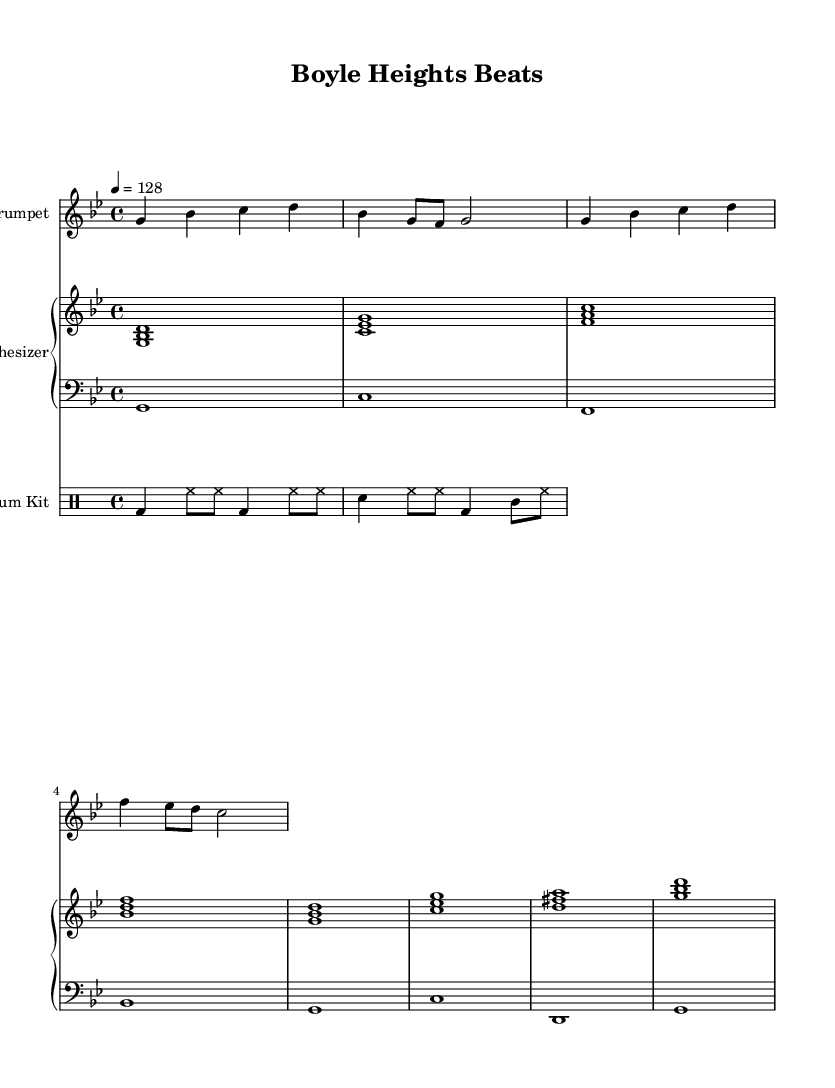What is the key signature of this music? The key signature indicates that the piece is in G minor, which typically has two flats (B flat and E flat). This can be inferred from the key signature symbol located at the beginning of the staff.
Answer: G minor What is the time signature of this piece? The time signature is shown as 4/4 at the beginning of the score, which means there are four beats in each measure and a quarter note gets one beat.
Answer: 4/4 What is the tempo of this composition? The tempo marking indicates that the piece is to be played at 128 beats per minute, which is noted in the tempo indication (4 = 128) at the top of the score.
Answer: 128 How many measures are in the mariachi trumpet part? By counting the measures in the mariachi trumpet staff, there are a total of 4 measures presented in the score.
Answer: 4 Which instruments are included in this score? The score includes a Mariachi Trumpet, a Synthesizer (with both harmony and bass parts), and a Drum Kit, as indicated by the labels at the beginning of each staff.
Answer: Mariachi Trumpet, Synthesizer, Drum Kit What type of rhythm pattern is primarily used in the drum section? The drum pattern combines bass drum (bd), hi-hat (hh), snare drum (sn), and crash cymbal (cl), creating a standard upbeat rhythm typical in electronic music. This can be seen in the specific notations for each type of drum in the drum staff.
Answer: Upbeat rhythm What characteristic of the harmony suggests a fusion of traditional and modern styles? The harmonic structure features traditional mariachi-like chords played by the synthesizer, which is combined with modern electronic production techniques, suggesting the blend of both musical styles.
Answer: Fusion of styles 